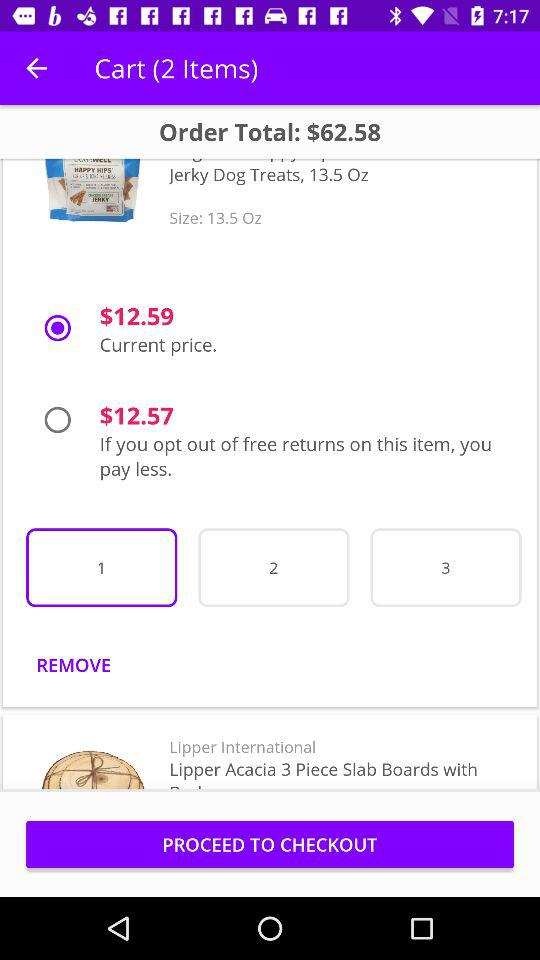What is the total number of items? The total number of items is 2. 